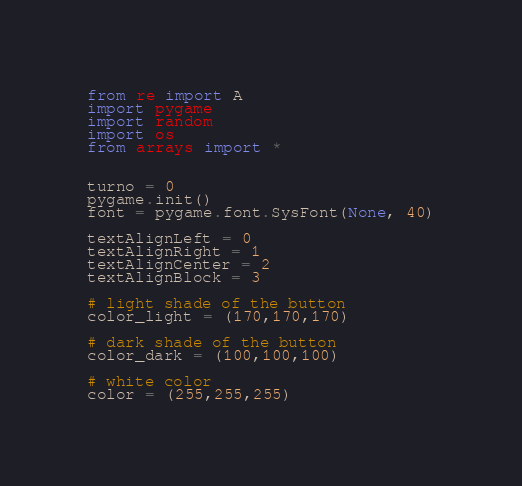<code> <loc_0><loc_0><loc_500><loc_500><_Python_>from re import A
import pygame
import random
import os
from arrays import *


turno = 0
pygame.init()
font = pygame.font.SysFont(None, 40)

textAlignLeft = 0
textAlignRight = 1
textAlignCenter = 2
textAlignBlock = 3

# light shade of the button
color_light = (170,170,170)

# dark shade of the button
color_dark = (100,100,100)

# white color
color = (255,255,255)
</code> 